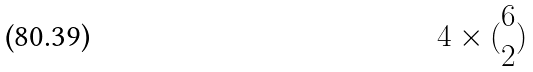Convert formula to latex. <formula><loc_0><loc_0><loc_500><loc_500>4 \times ( \begin{matrix} 6 \\ 2 \end{matrix} )</formula> 